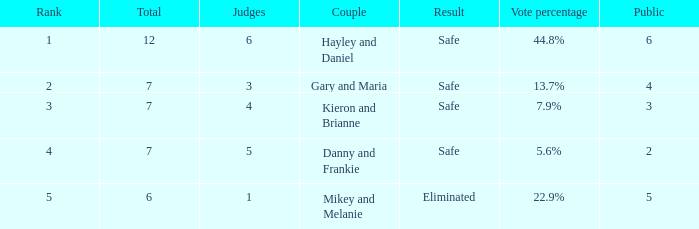What was the result for the total of 12? Safe. 